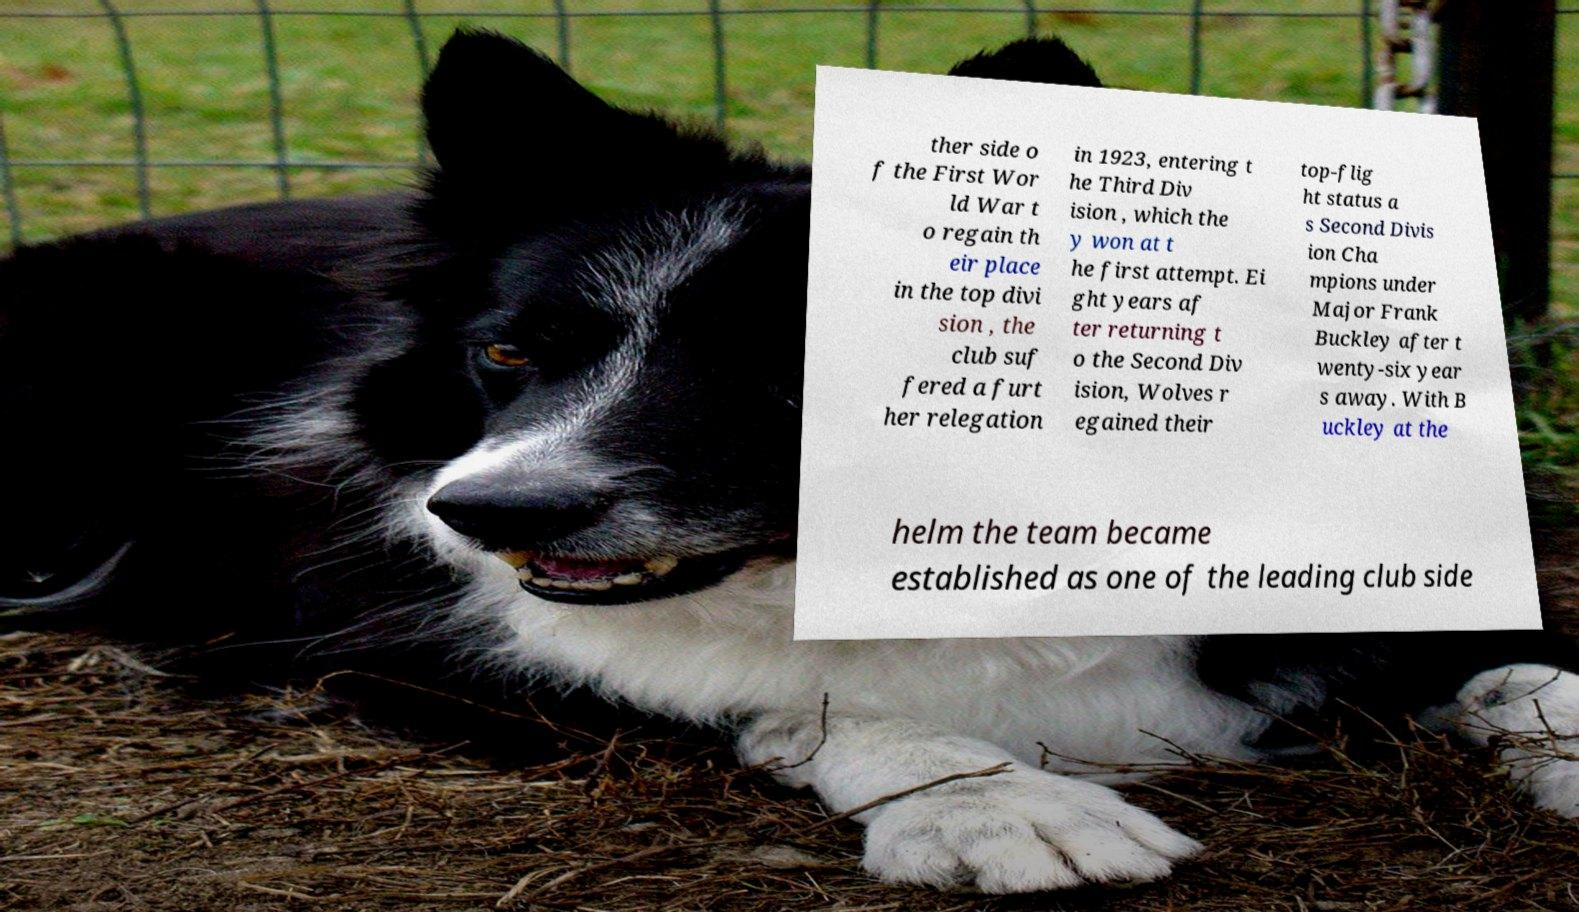Can you accurately transcribe the text from the provided image for me? ther side o f the First Wor ld War t o regain th eir place in the top divi sion , the club suf fered a furt her relegation in 1923, entering t he Third Div ision , which the y won at t he first attempt. Ei ght years af ter returning t o the Second Div ision, Wolves r egained their top-flig ht status a s Second Divis ion Cha mpions under Major Frank Buckley after t wenty-six year s away. With B uckley at the helm the team became established as one of the leading club side 